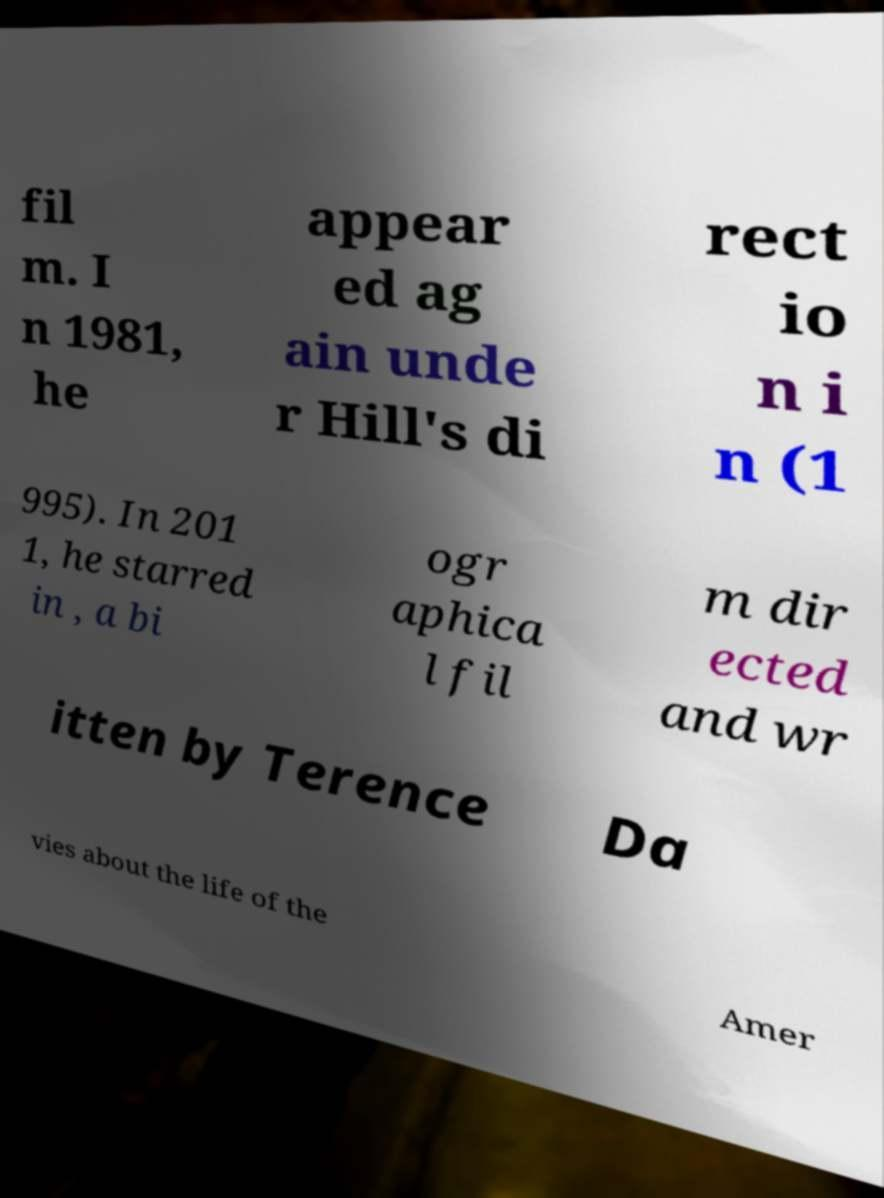Please identify and transcribe the text found in this image. fil m. I n 1981, he appear ed ag ain unde r Hill's di rect io n i n (1 995). In 201 1, he starred in , a bi ogr aphica l fil m dir ected and wr itten by Terence Da vies about the life of the Amer 